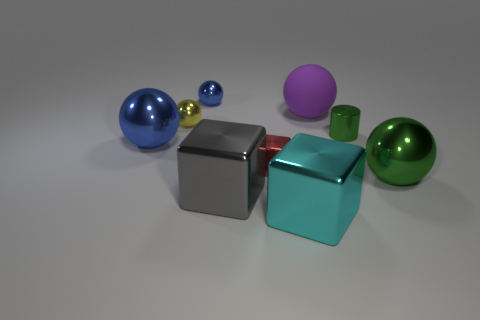Subtract all yellow balls. How many balls are left? 4 Subtract all yellow spheres. How many spheres are left? 4 Subtract all red spheres. Subtract all blue cylinders. How many spheres are left? 5 Subtract all spheres. How many objects are left? 4 Add 7 large gray metallic blocks. How many large gray metallic blocks exist? 8 Subtract 0 cyan cylinders. How many objects are left? 9 Subtract all blue matte balls. Subtract all yellow metal things. How many objects are left? 8 Add 1 large green metal objects. How many large green metal objects are left? 2 